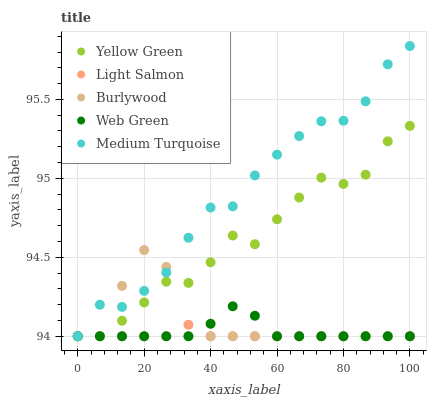Does Light Salmon have the minimum area under the curve?
Answer yes or no. Yes. Does Medium Turquoise have the maximum area under the curve?
Answer yes or no. Yes. Does Yellow Green have the minimum area under the curve?
Answer yes or no. No. Does Yellow Green have the maximum area under the curve?
Answer yes or no. No. Is Light Salmon the smoothest?
Answer yes or no. Yes. Is Burlywood the roughest?
Answer yes or no. Yes. Is Yellow Green the smoothest?
Answer yes or no. No. Is Yellow Green the roughest?
Answer yes or no. No. Does Burlywood have the lowest value?
Answer yes or no. Yes. Does Medium Turquoise have the highest value?
Answer yes or no. Yes. Does Yellow Green have the highest value?
Answer yes or no. No. Does Web Green intersect Medium Turquoise?
Answer yes or no. Yes. Is Web Green less than Medium Turquoise?
Answer yes or no. No. Is Web Green greater than Medium Turquoise?
Answer yes or no. No. 